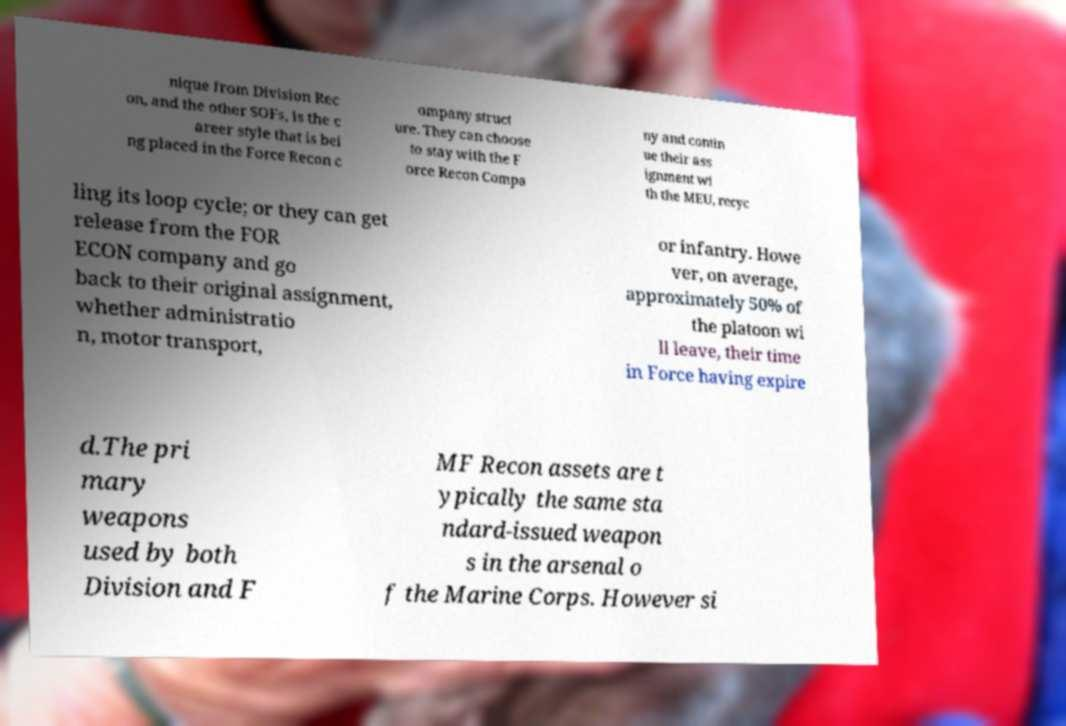Can you read and provide the text displayed in the image?This photo seems to have some interesting text. Can you extract and type it out for me? nique from Division Rec on, and the other SOFs, is the c areer style that is bei ng placed in the Force Recon c ompany struct ure. They can choose to stay with the F orce Recon Compa ny and contin ue their ass ignment wi th the MEU, recyc ling its loop cycle; or they can get release from the FOR ECON company and go back to their original assignment, whether administratio n, motor transport, or infantry. Howe ver, on average, approximately 50% of the platoon wi ll leave, their time in Force having expire d.The pri mary weapons used by both Division and F MF Recon assets are t ypically the same sta ndard-issued weapon s in the arsenal o f the Marine Corps. However si 